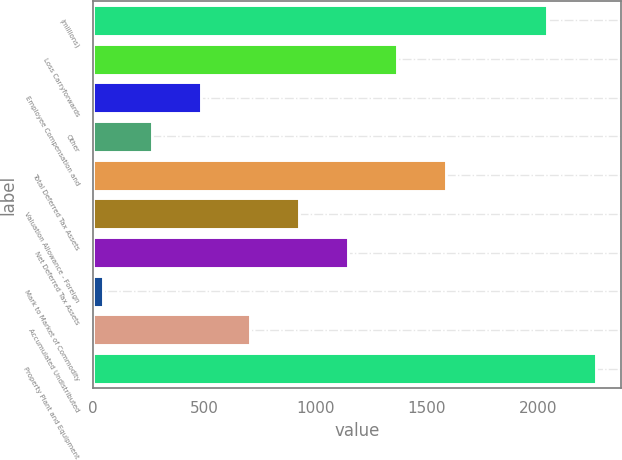Convert chart. <chart><loc_0><loc_0><loc_500><loc_500><bar_chart><fcel>(millions)<fcel>Loss Carryforwards<fcel>Employee Compensation and<fcel>Other<fcel>Total Deferred Tax Assets<fcel>Valuation Allowance - Foreign<fcel>Net Deferred Tax Assets<fcel>Mark to Market of Commodity<fcel>Accumulated Undistributed<fcel>Property Plant and Equipment<nl><fcel>2039.6<fcel>1367.6<fcel>485.2<fcel>264.6<fcel>1588.2<fcel>926.4<fcel>1147<fcel>44<fcel>705.8<fcel>2260.2<nl></chart> 